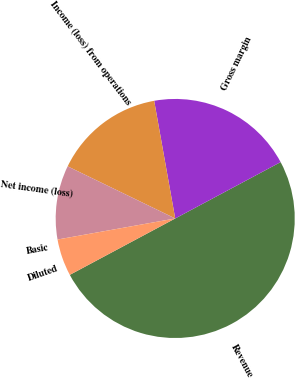Convert chart. <chart><loc_0><loc_0><loc_500><loc_500><pie_chart><fcel>Revenue<fcel>Gross margin<fcel>Income (loss) from operations<fcel>Net income (loss)<fcel>Basic<fcel>Diluted<nl><fcel>50.0%<fcel>20.0%<fcel>15.0%<fcel>10.0%<fcel>0.0%<fcel>5.0%<nl></chart> 